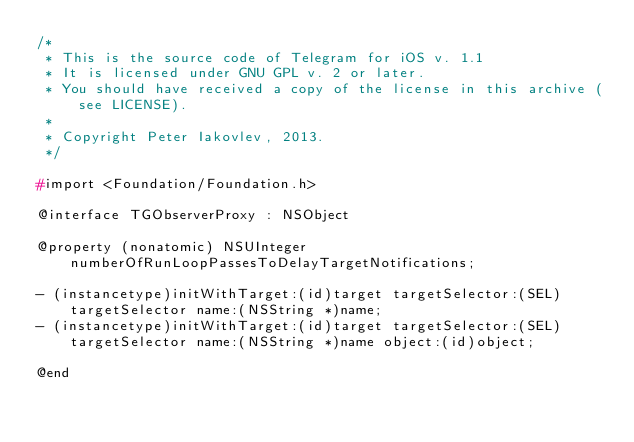Convert code to text. <code><loc_0><loc_0><loc_500><loc_500><_C_>/*
 * This is the source code of Telegram for iOS v. 1.1
 * It is licensed under GNU GPL v. 2 or later.
 * You should have received a copy of the license in this archive (see LICENSE).
 *
 * Copyright Peter Iakovlev, 2013.
 */

#import <Foundation/Foundation.h>

@interface TGObserverProxy : NSObject

@property (nonatomic) NSUInteger numberOfRunLoopPassesToDelayTargetNotifications;

- (instancetype)initWithTarget:(id)target targetSelector:(SEL)targetSelector name:(NSString *)name;
- (instancetype)initWithTarget:(id)target targetSelector:(SEL)targetSelector name:(NSString *)name object:(id)object;

@end
</code> 